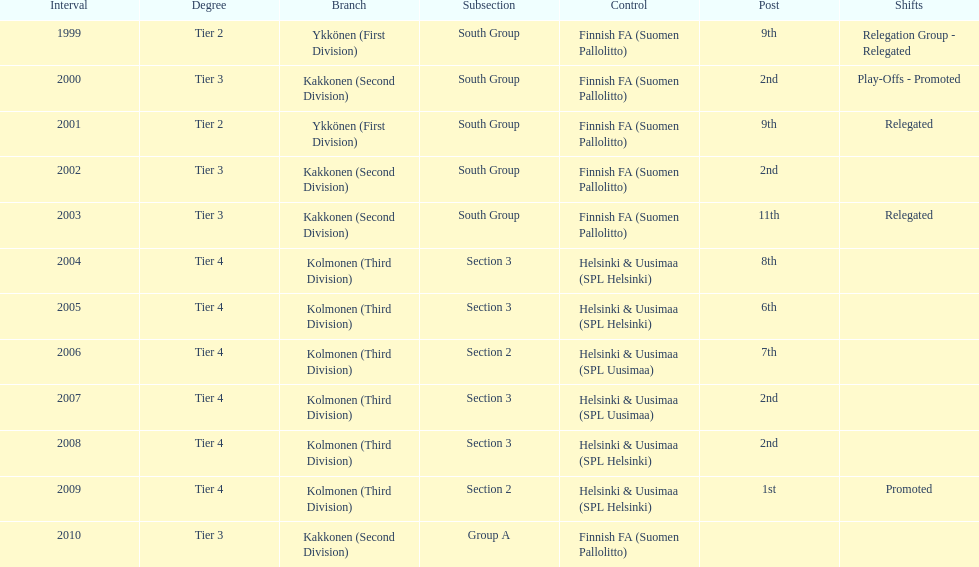How many times were they in tier 3? 4. 